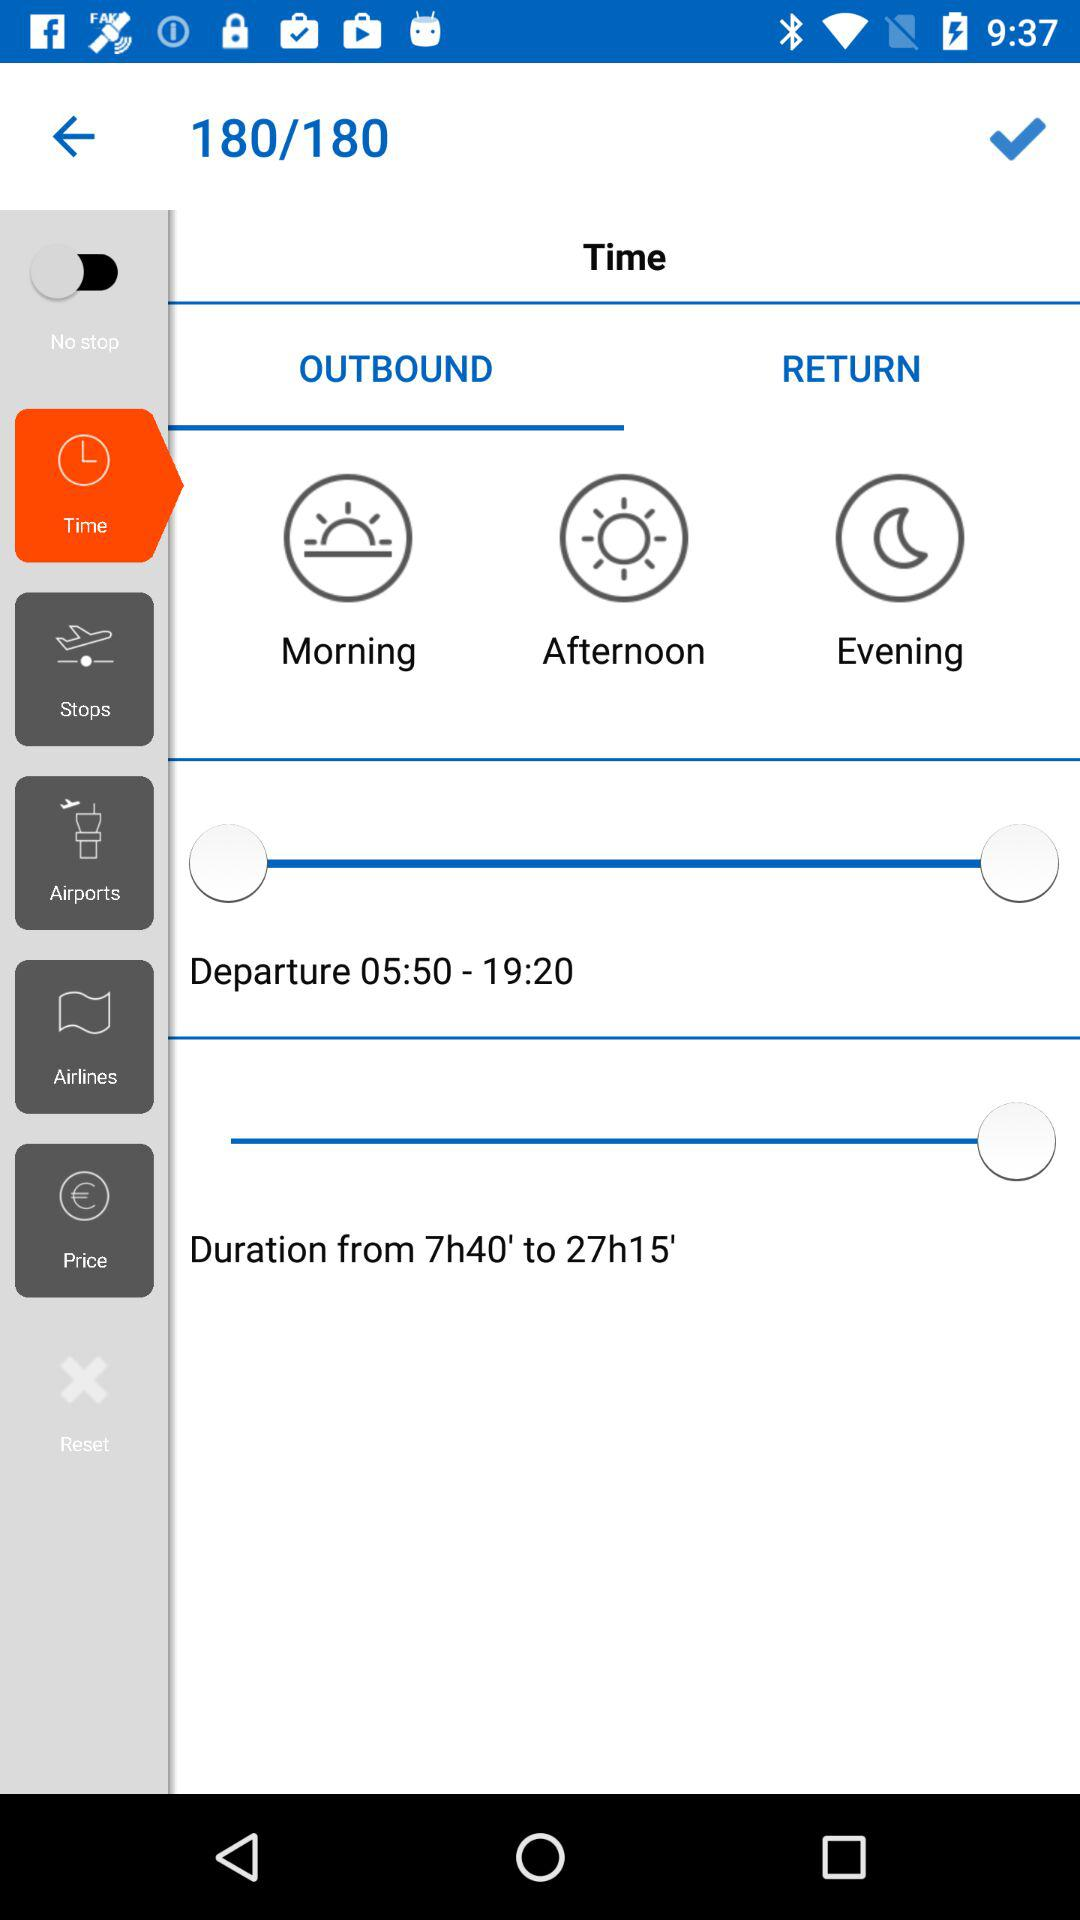What is the departure time? The departure time is from 05:50 A.M. to 19:20 P.M. 